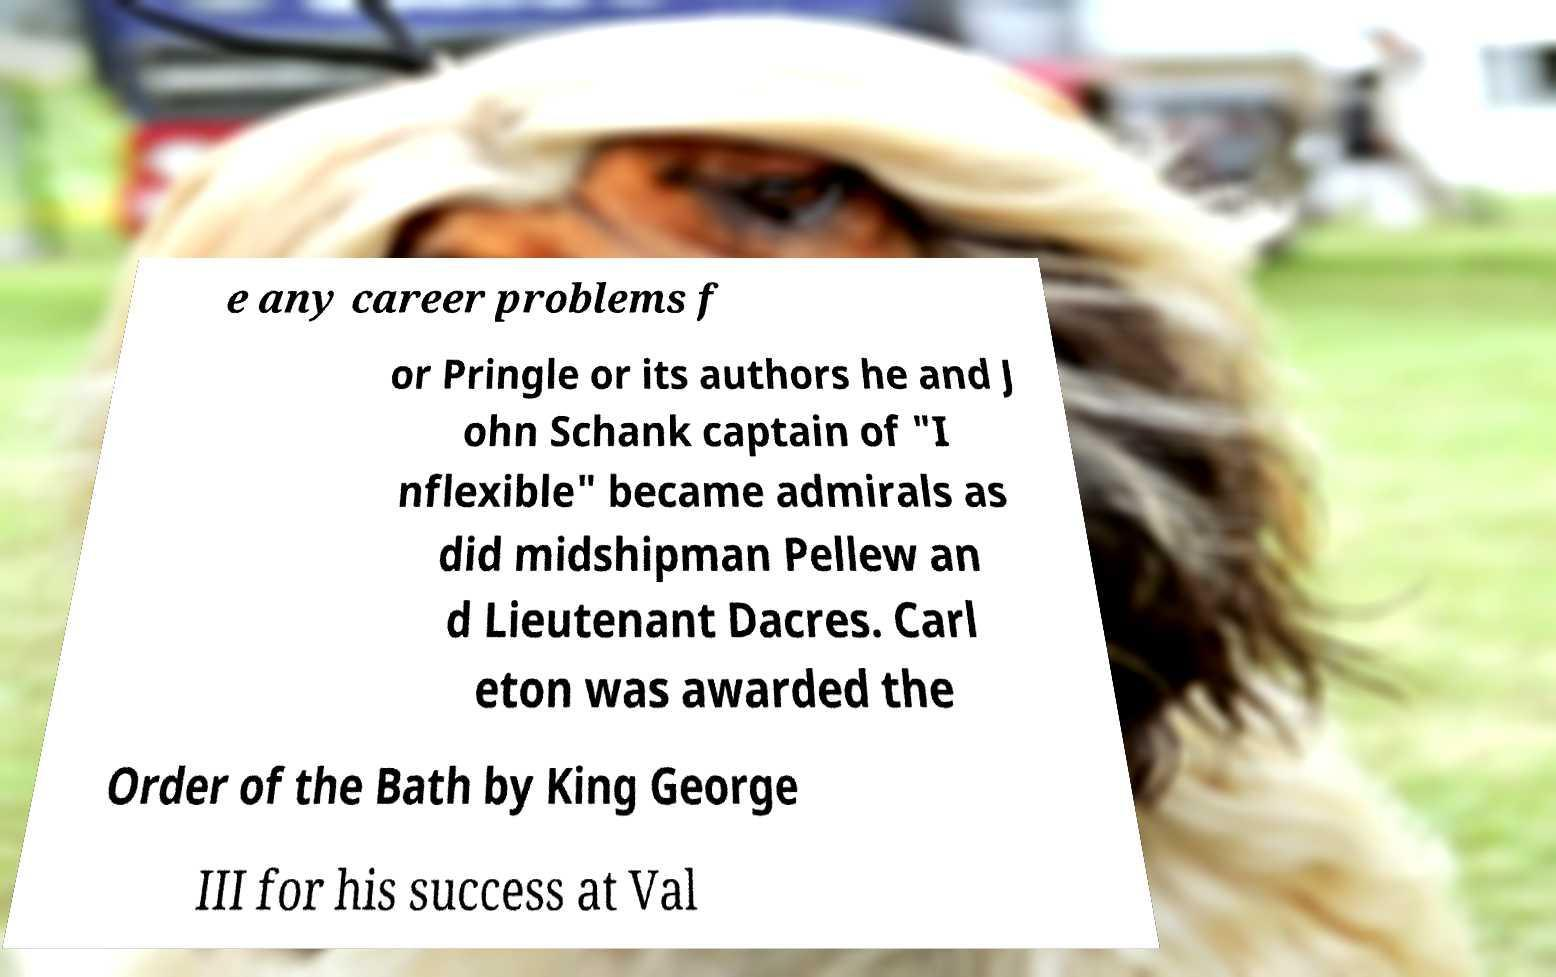Can you read and provide the text displayed in the image?This photo seems to have some interesting text. Can you extract and type it out for me? e any career problems f or Pringle or its authors he and J ohn Schank captain of "I nflexible" became admirals as did midshipman Pellew an d Lieutenant Dacres. Carl eton was awarded the Order of the Bath by King George III for his success at Val 